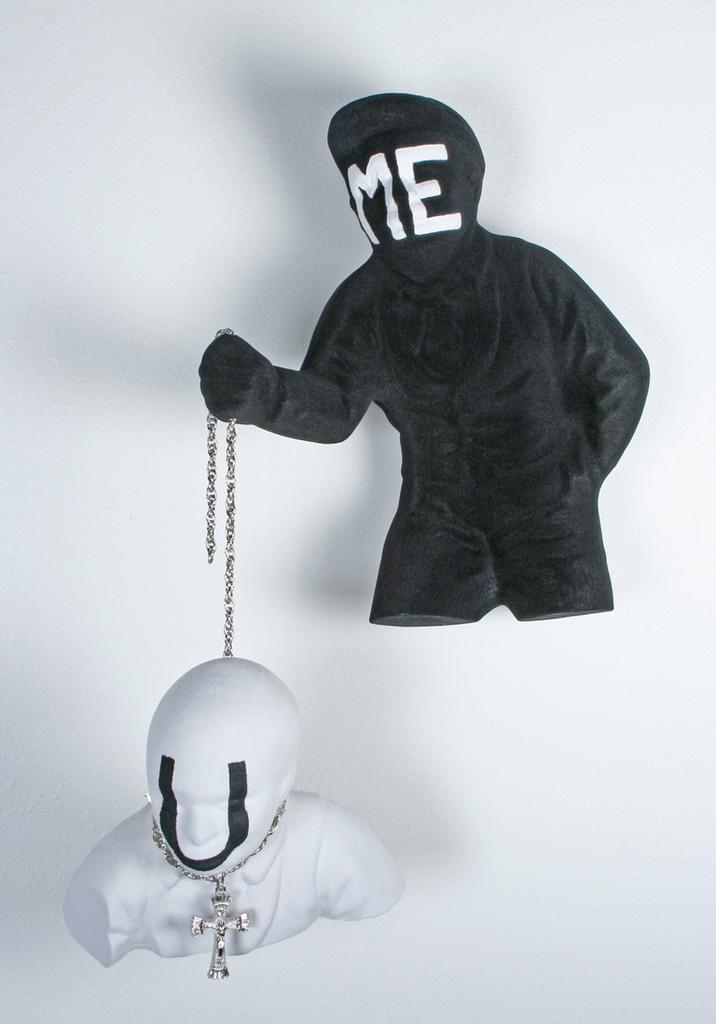What is the color of the wall in the image? The wall in the image is white. What is the color of the jacket in the image? The jacket in the image is black. What is the human statue doing in the image? The human statue is holding the jacket. How many chairs are visible in the image? There are no chairs present in the image. What type of doll is being pulled by the human statue in the image? There is no doll present in the image, and the human statue is not pulling anything. 